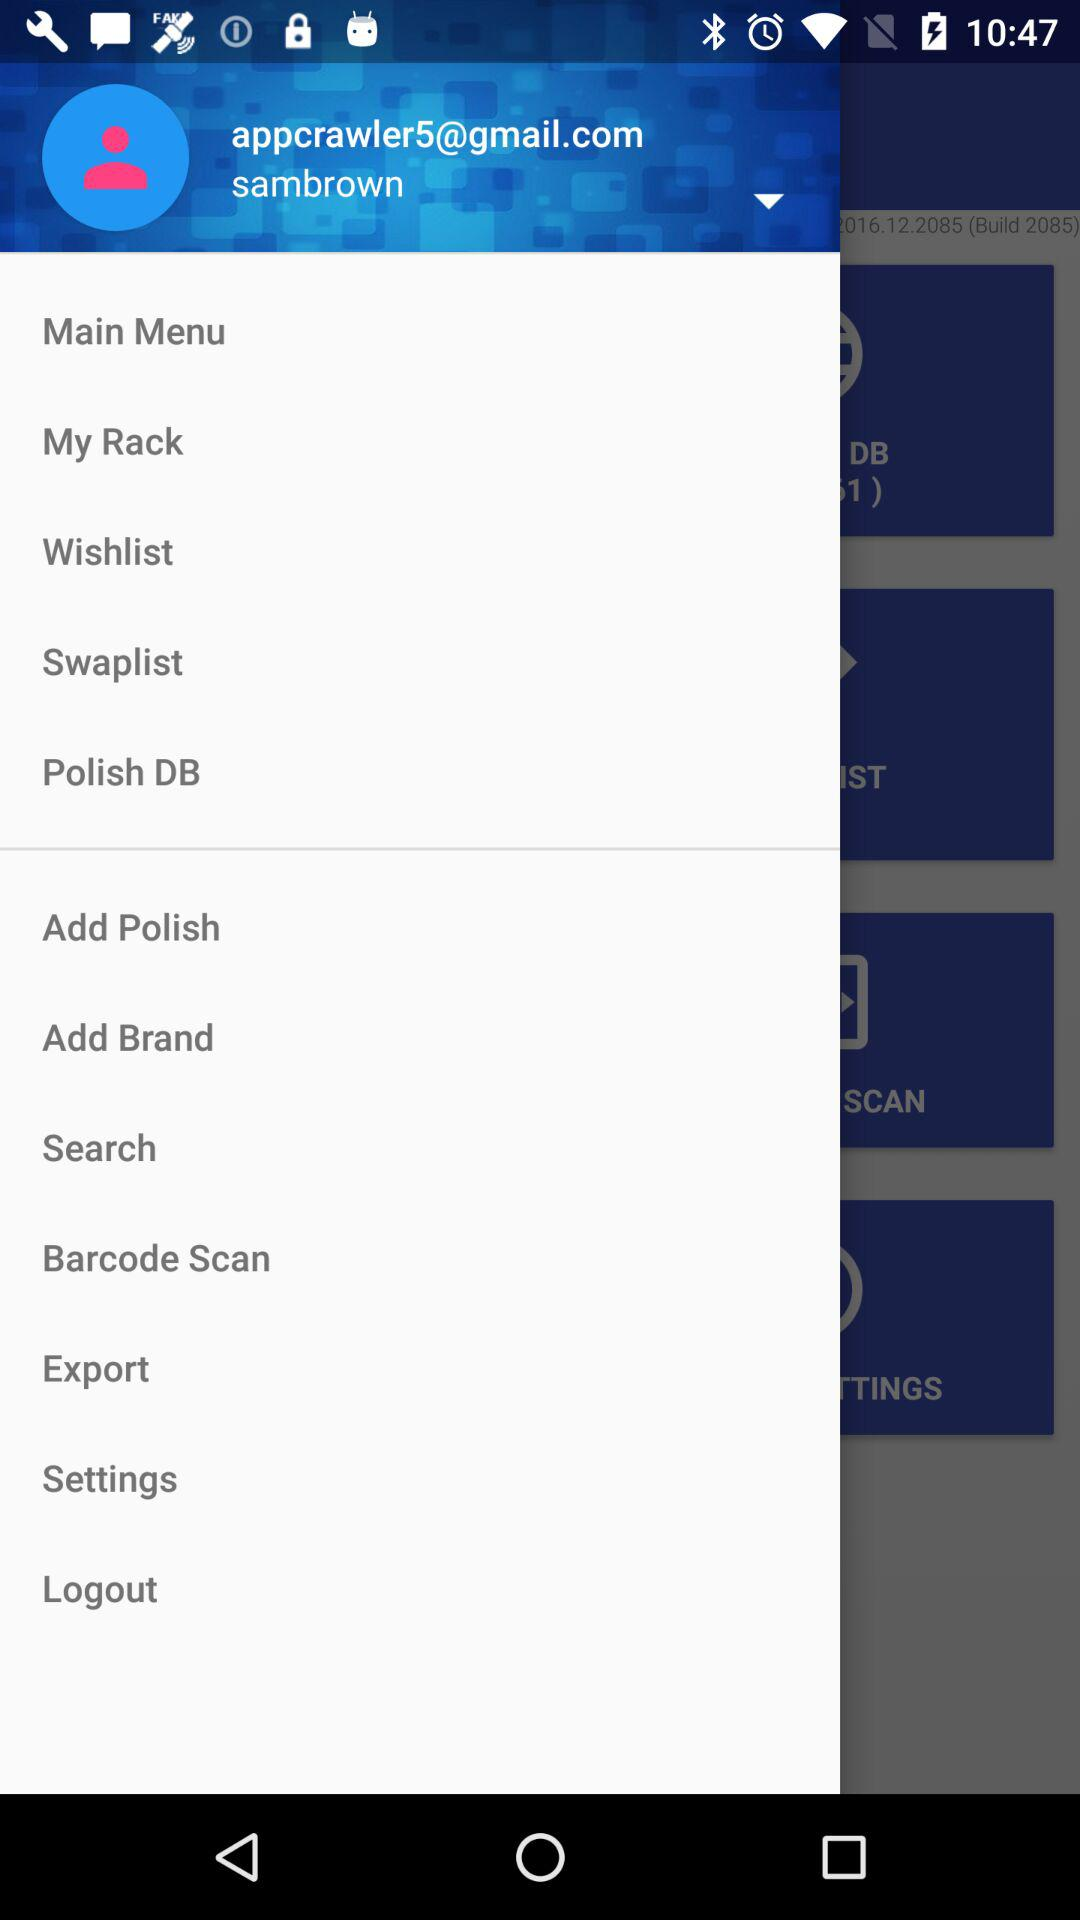What is the name of the user? The name of the user is Sambrown. 